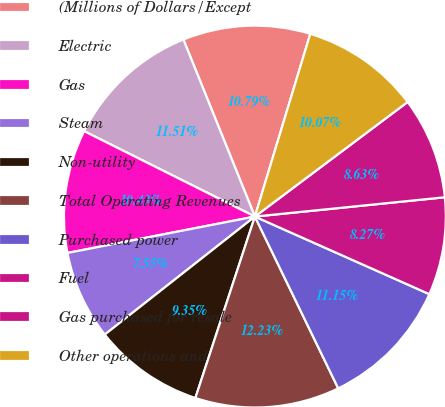Convert chart to OTSL. <chart><loc_0><loc_0><loc_500><loc_500><pie_chart><fcel>(Millions of Dollars/Except<fcel>Electric<fcel>Gas<fcel>Steam<fcel>Non-utility<fcel>Total Operating Revenues<fcel>Purchased power<fcel>Fuel<fcel>Gas purchased for resale<fcel>Other operations and<nl><fcel>10.79%<fcel>11.51%<fcel>10.43%<fcel>7.55%<fcel>9.35%<fcel>12.23%<fcel>11.15%<fcel>8.27%<fcel>8.63%<fcel>10.07%<nl></chart> 